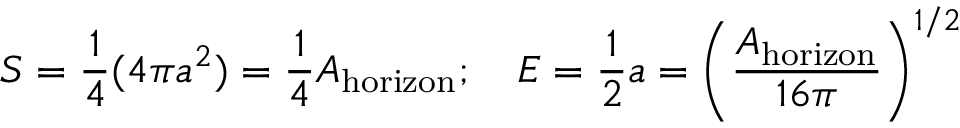<formula> <loc_0><loc_0><loc_500><loc_500>S = { \frac { 1 } { 4 } } ( 4 \pi a ^ { 2 } ) = { \frac { 1 } { 4 } } A _ { h o r i z o n } ; \quad E = { \frac { 1 } { 2 } } a = \left ( { \frac { A _ { h o r i z o n } } { 1 6 \pi } } \right ) ^ { 1 / 2 }</formula> 